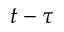<formula> <loc_0><loc_0><loc_500><loc_500>t - \tau</formula> 